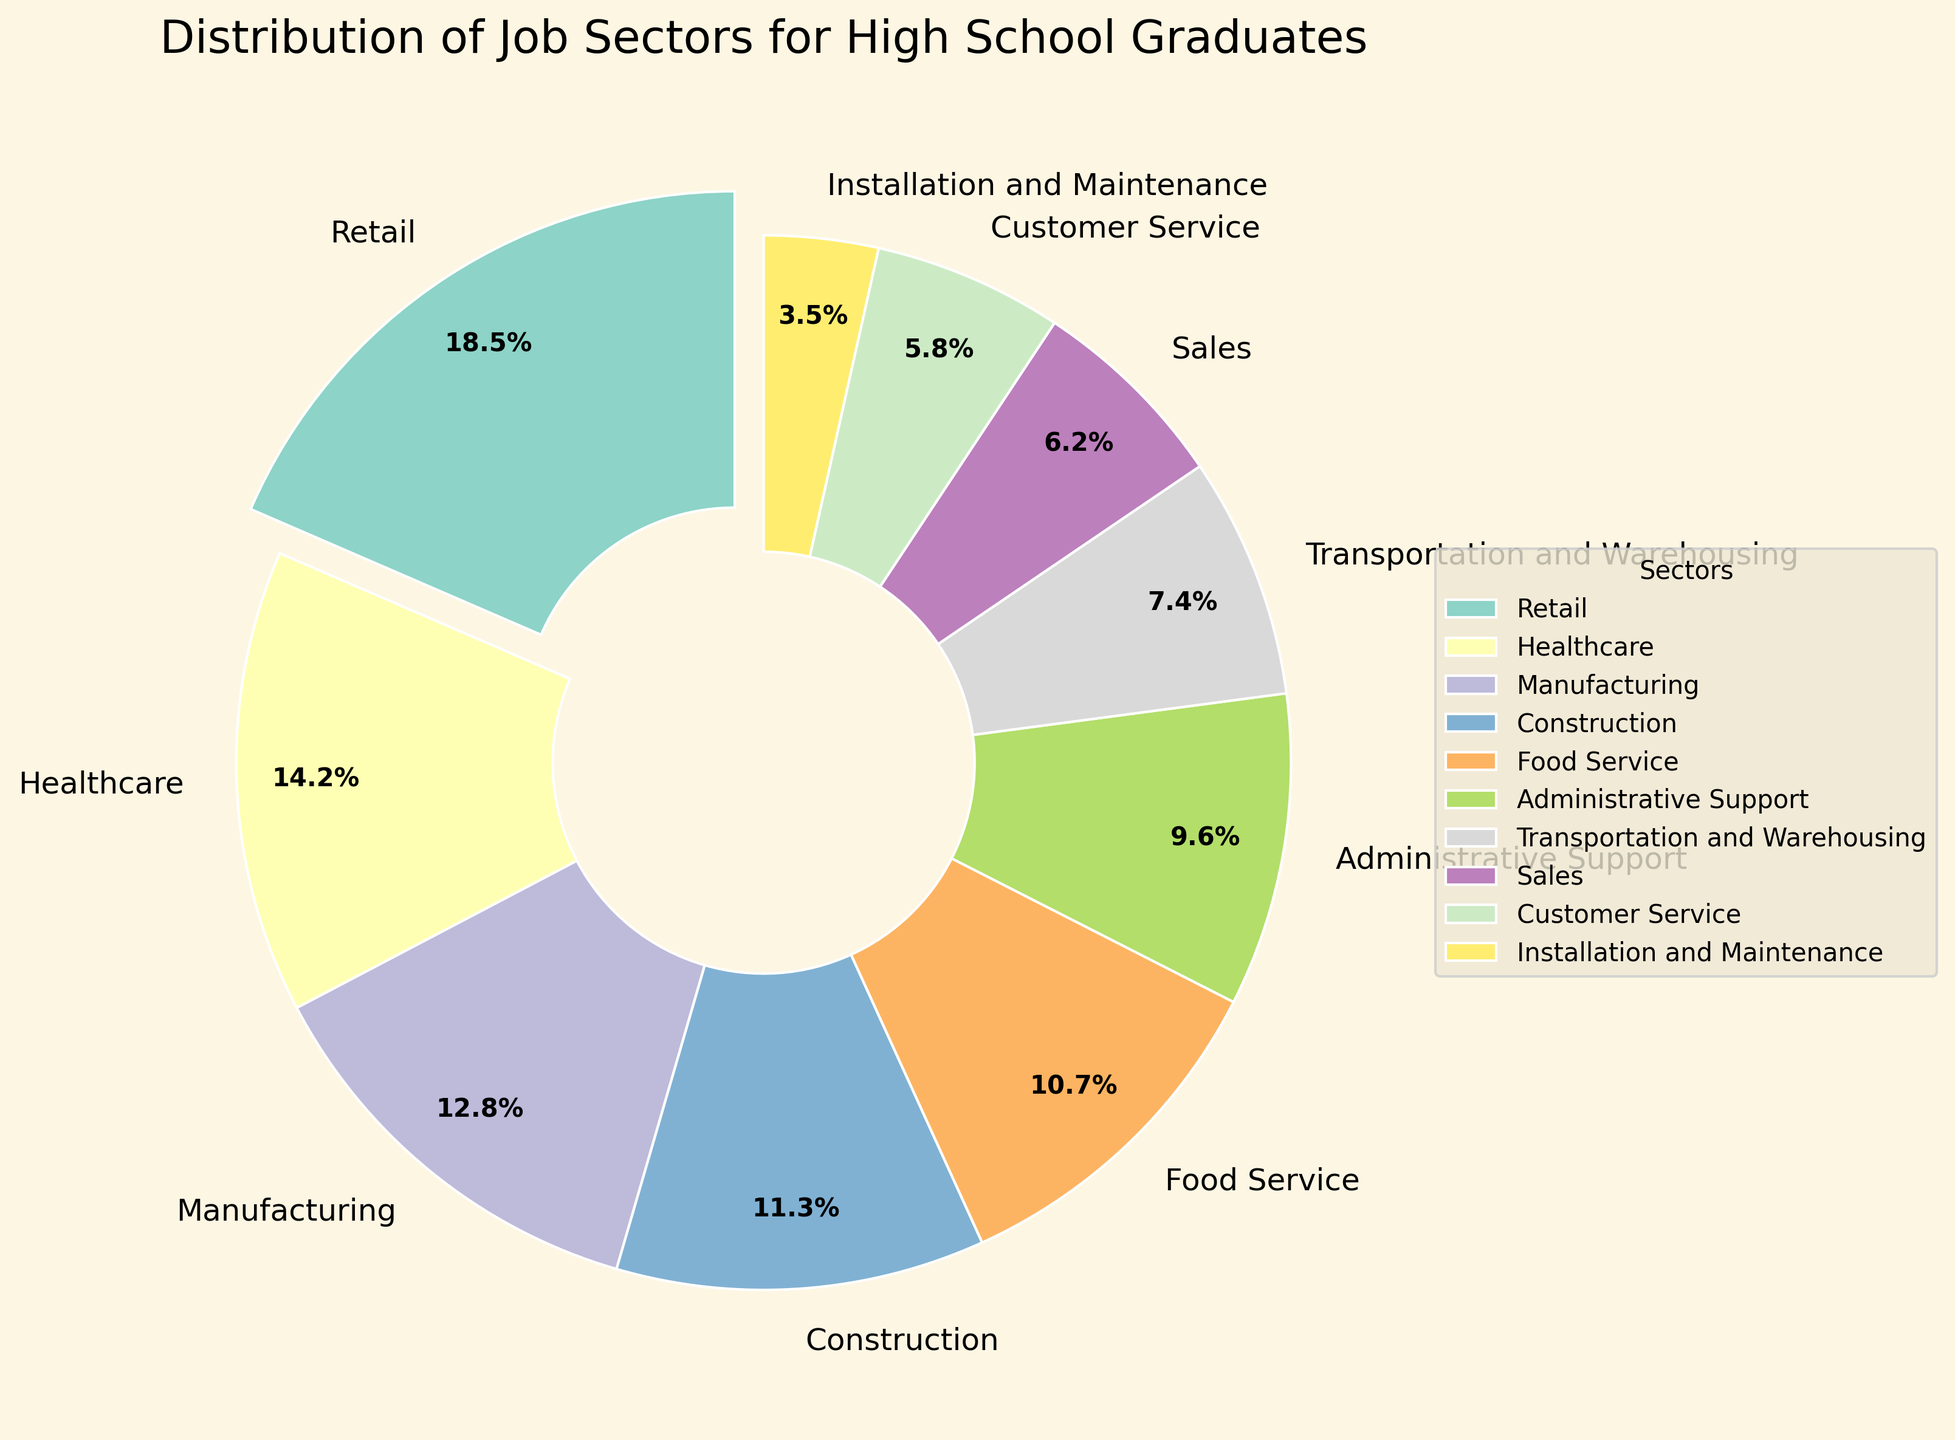What is the highest percentage sector? The pie chart uses an exploded slice to emphasize the sector with the highest percentage. By identifying the exploded slice, we see that Retail has the highest percentage.
Answer: Retail How much larger is the percentage of Retail compared to Sales? From the pie chart, Retail is 18.5% and Sales is 6.2%. Subtracting Sales from Retail gives 18.5% - 6.2% = 12.3%.
Answer: 12.3% Which two sectors have the smallest percentages, and what are their combined values? Looking at the percentages, Installation and Maintenance (3.5%) and Customer Service (5.8%) are the smallest. Their combined value is 3.5% + 5.8% = 9.3%.
Answer: Installation and Maintenance, Customer Service, 9.3% What is the total percentage of job sectors that are not visually assigned round numbers (integers)? Percentages that are not whole numbers include Retail (18.5%), Healthcare (14.2%), Manufacturing (12.8%), Food Service (10.7%), Administrative Support (9.6%), and Customer Service (5.8%). Adding these gives a total of 18.5% + 14.2% + 12.8% + 10.7% + 9.6% + 5.8% = 71.6%.
Answer: 71.6% How does Transportation and Warehousing compare to Administrative Support in terms of percentage? From the pie chart, Transportation and Warehousing is at 7.4% and Administrative Support is at 9.6%. Thus, Administrative Support has a greater percentage by 9.6% - 7.4% = 2.2%.
Answer: Administrative Support is 2.2% higher What is the combined percentage of Manufacturing, Construction, and Food Service? Adding the percentages of Manufacturing (12.8%), Construction (11.3%), and Food Service (10.7%) gives 12.8% + 11.3% + 10.7% = 34.8%.
Answer: 34.8% Identify the sector with the smallest percentage and state the color used to represent it. The smallest sector is Installation and Maintenance with 3.5%. According to the color scheme used in the pie chart, this is represented in a lighter blueish-green hue from the Set3 colormap.
Answer: Installation and Maintenance, lighter blueish-green What sectors make up over 50% of the distribution combined? By summing the largest percentage sectors until exceeding 50%, we find Retail (18.5%), Healthcare (14.2%), and Manufacturing (12.8%) total 18.5% + 14.2% + 12.8% = 45.5%. Including Construction (11.3%) gives a combined value of 45.5% + 11.3% = 56.8%.
Answer: Retail, Healthcare, Manufacturing, and Construction If you were to merge the percentages of Sales and Customer Service, would it exceed the percentage of Food Service? By how much? The sum of Sales (6.2%) and Customer Service (5.8%) is 6.2% + 5.8% = 12%. Comparing to Food Service (10.7%), the merged percentage exceeds Food Service by 12% - 10.7% = 1.3%.
Answer: Yes, by 1.3% 